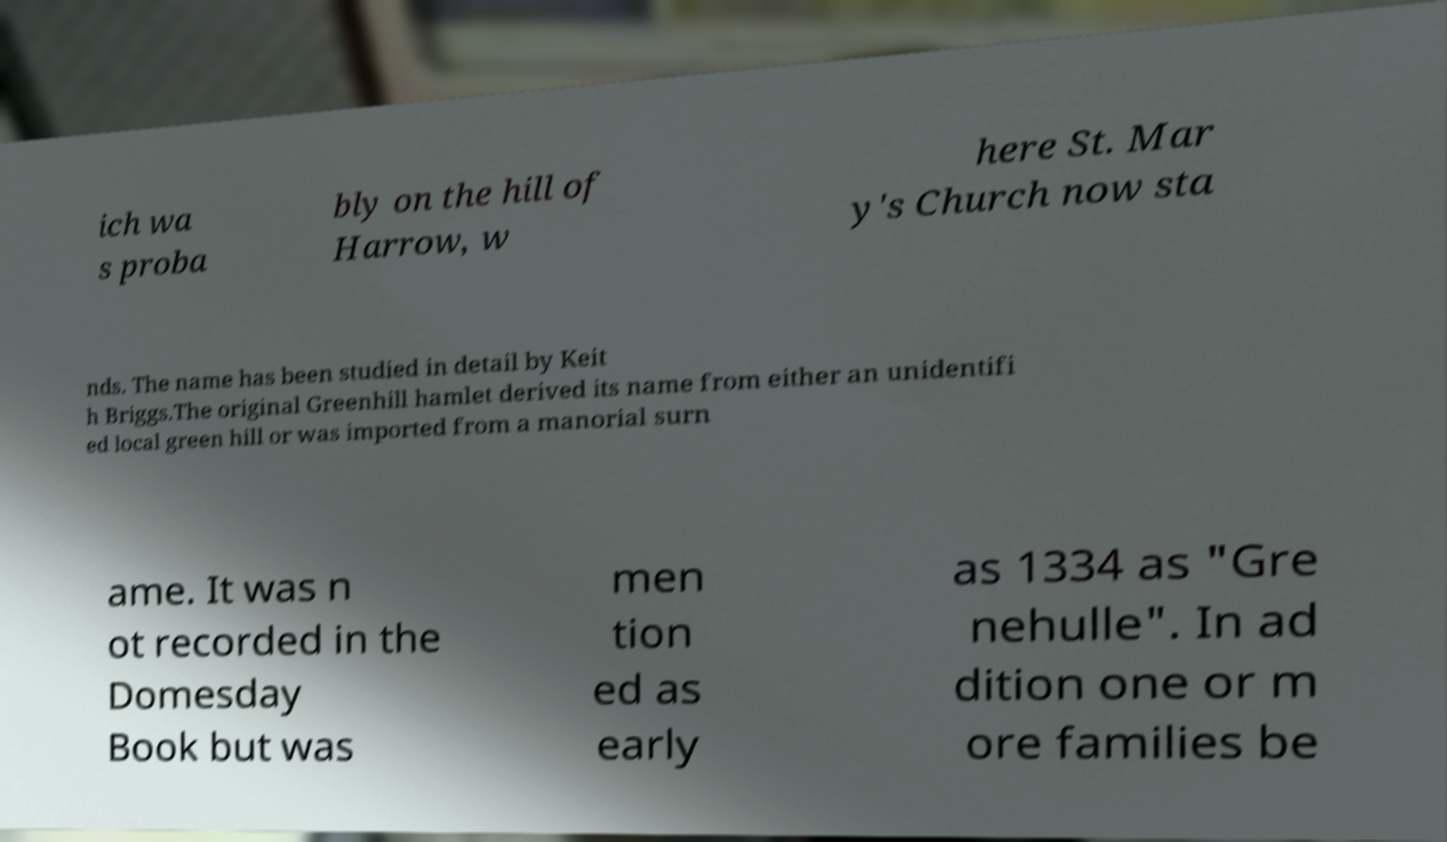Can you read and provide the text displayed in the image?This photo seems to have some interesting text. Can you extract and type it out for me? ich wa s proba bly on the hill of Harrow, w here St. Mar y's Church now sta nds. The name has been studied in detail by Keit h Briggs.The original Greenhill hamlet derived its name from either an unidentifi ed local green hill or was imported from a manorial surn ame. It was n ot recorded in the Domesday Book but was men tion ed as early as 1334 as "Gre nehulle". In ad dition one or m ore families be 